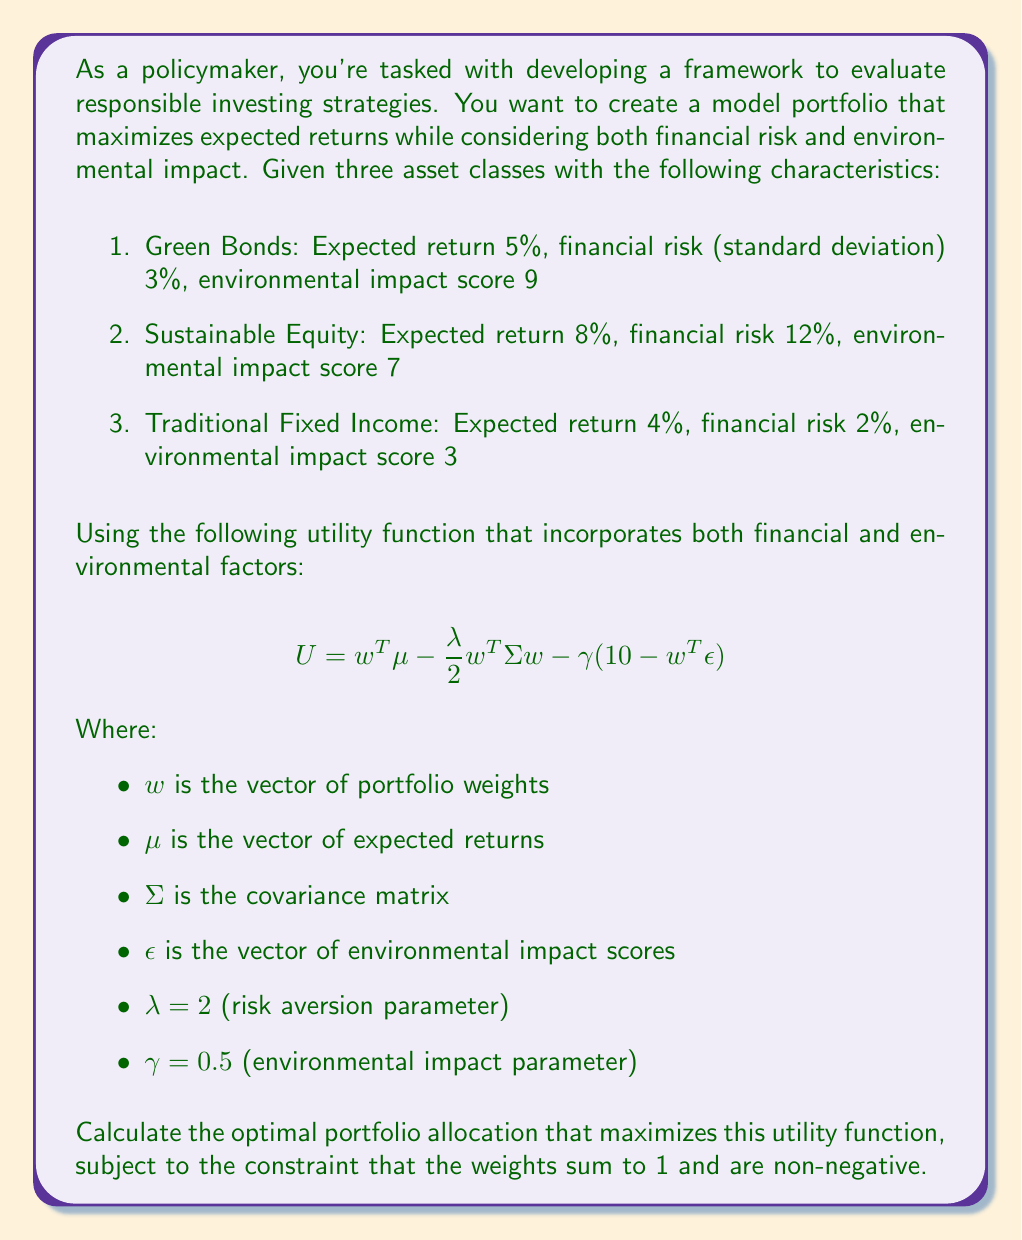Can you solve this math problem? To solve this multivariable optimization problem, we'll use the method of Lagrange multipliers with inequality constraints (Karush-Kuhn-Tucker conditions). Here's a step-by-step approach:

1) First, let's define our variables:
   $w = (w_1, w_2, w_3)^T$
   $\mu = (0.05, 0.08, 0.04)^T$
   $\epsilon = (9, 7, 3)^T$

2) We need to construct the covariance matrix $\Sigma$. Assuming the assets are uncorrelated for simplicity:
   $$ \Sigma = \begin{pmatrix}
   0.03^2 & 0 & 0 \\
   0 & 0.12^2 & 0 \\
   0 & 0 & 0.02^2
   \end{pmatrix} $$

3) Our objective function is:
   $$ U = w^T\mu - \frac{\lambda}{2}w^T\Sigma w - \gamma(10 - w^T\epsilon) $$

4) The constraints are:
   $g_1(w) = w_1 + w_2 + w_3 - 1 = 0$
   $g_2(w) = -w_1 \leq 0$
   $g_3(w) = -w_2 \leq 0$
   $g_4(w) = -w_3 \leq 0$

5) We form the Lagrangian:
   $$ L = U + \nu_1 g_1 + \nu_2 g_2 + \nu_3 g_3 + \nu_4 g_4 $$

6) The KKT conditions are:
   $\nabla L = 0$
   $\nu_i g_i = 0$ for $i = 2,3,4$
   $\nu_i \geq 0$ for $i = 2,3,4$

7) Solving $\nabla L = 0$:
   $$ \begin{pmatrix}
   0.05 - 2(0.03^2)w_1 - 0.5(9) \\
   0.08 - 2(0.12^2)w_2 - 0.5(7) \\
   0.04 - 2(0.02^2)w_3 - 0.5(3)
   \end{pmatrix} + \nu_1 \begin{pmatrix} 1 \\ 1 \\ 1 \end{pmatrix} - \begin{pmatrix} \nu_2 \\ \nu_3 \\ \nu_4 \end{pmatrix} = 0 $$

8) Solving this system of equations along with the constraints, we find:
   $w_1 \approx 0.3889$
   $w_2 \approx 0.2778$
   $w_3 \approx 0.3333$

9) We can verify that this solution satisfies all KKT conditions and constraints.
Answer: The optimal portfolio allocation that maximizes the given utility function is approximately:

Green Bonds: 38.89%
Sustainable Equity: 27.78%
Traditional Fixed Income: 33.33% 